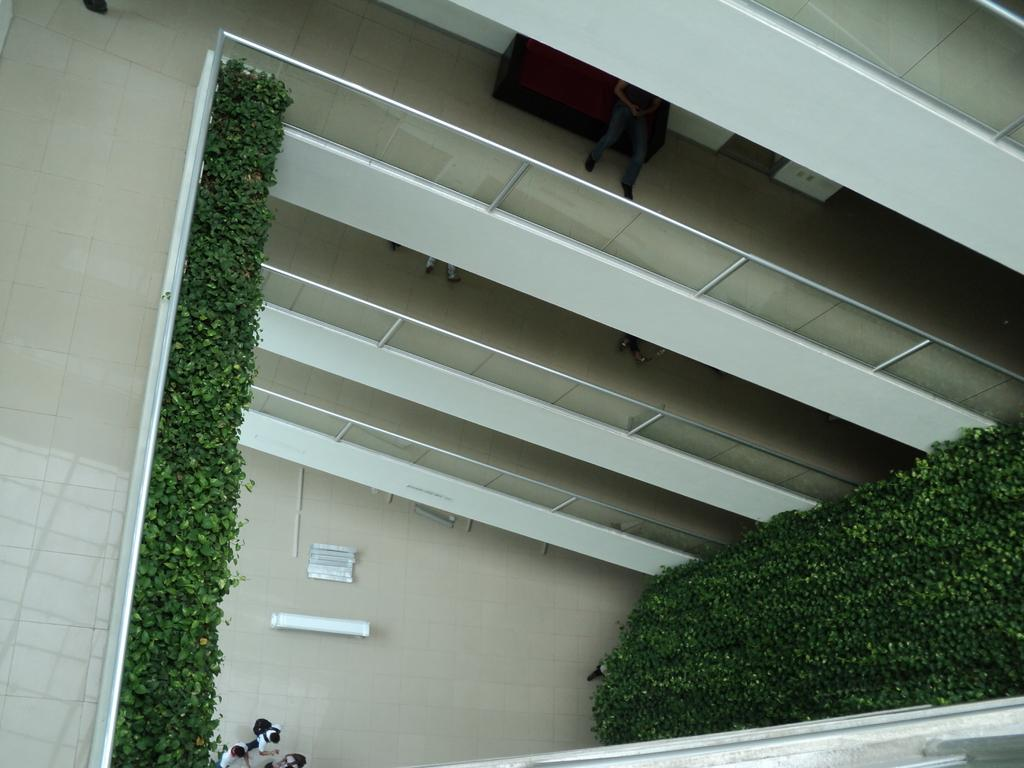What is the person in the image doing? The person in the image is sitting on a couch. What are the people on the ground floor doing? The people on the ground floor are standing. What type of vegetation can be seen in the image? Decorative trees are present in the image. What else can be seen on the ground floor in the image? Other items are visible on the ground floor in the image. What type of land can be seen in the image? There is no land visible in the image, as it appears to be an indoor setting. What type of eggnog is being served on the couch? There is no eggnog present in the image; it features a person sitting on a couch and other people standing on the ground floor. 